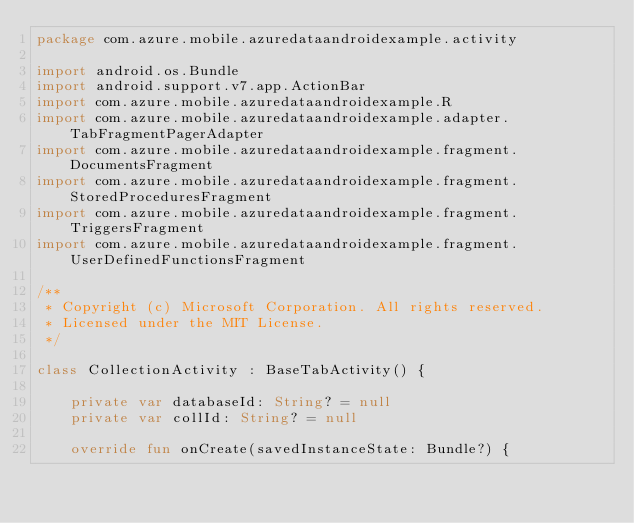<code> <loc_0><loc_0><loc_500><loc_500><_Kotlin_>package com.azure.mobile.azuredataandroidexample.activity

import android.os.Bundle
import android.support.v7.app.ActionBar
import com.azure.mobile.azuredataandroidexample.R
import com.azure.mobile.azuredataandroidexample.adapter.TabFragmentPagerAdapter
import com.azure.mobile.azuredataandroidexample.fragment.DocumentsFragment
import com.azure.mobile.azuredataandroidexample.fragment.StoredProceduresFragment
import com.azure.mobile.azuredataandroidexample.fragment.TriggersFragment
import com.azure.mobile.azuredataandroidexample.fragment.UserDefinedFunctionsFragment

/**
 * Copyright (c) Microsoft Corporation. All rights reserved.
 * Licensed under the MIT License.
 */

class CollectionActivity : BaseTabActivity() {

    private var databaseId: String? = null
    private var collId: String? = null

    override fun onCreate(savedInstanceState: Bundle?) {
</code> 